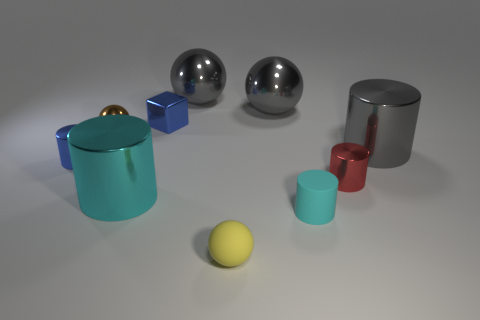If this image were a part of an advertisement, what product do you think it might be promoting? If this image were part of an advertisement, it might be promoting a product related to home decor or design, such as modern minimalist furniture, due to the simple yet elegant shapes of the objects and the clean, neutral background which conveys a sleek, contemporary aesthetic. 